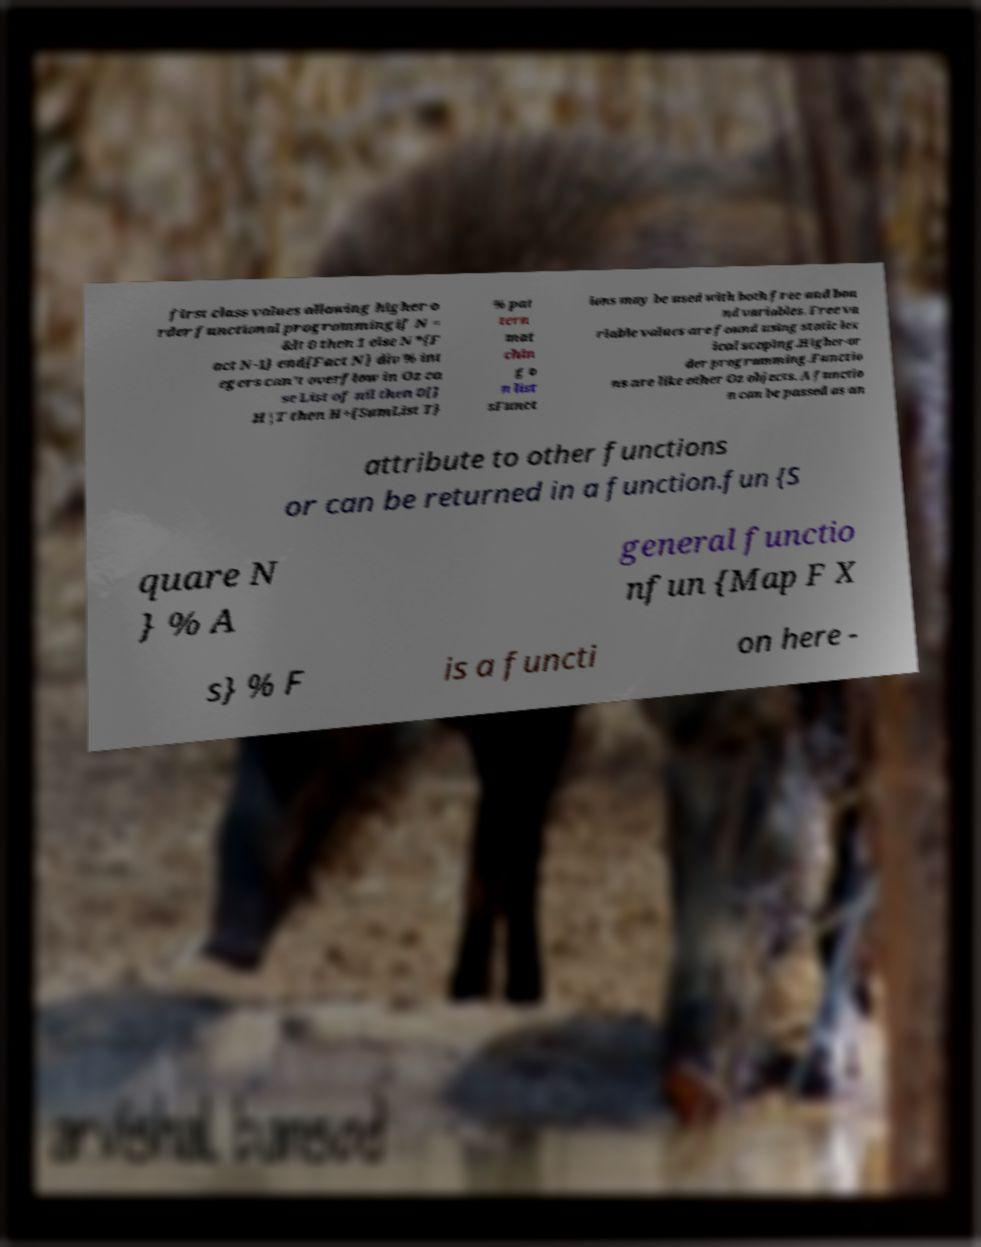Could you assist in decoding the text presented in this image and type it out clearly? first class values allowing higher o rder functional programmingif N = &lt 0 then 1 else N*{F act N-1} end{Fact N} div % int egers can't overflow in Oz ca se List of nil then 0[] H|T then H+{SumList T} % pat tern mat chin g o n list sFunct ions may be used with both free and bou nd variables. Free va riable values are found using static lex ical scoping.Higher-or der programming.Functio ns are like other Oz objects. A functio n can be passed as an attribute to other functions or can be returned in a function.fun {S quare N } % A general functio nfun {Map F X s} % F is a functi on here - 